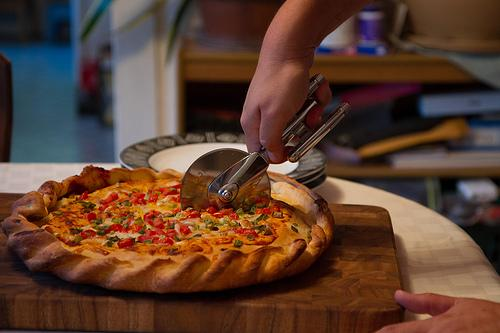Describe the type of pizza in the image and the surface on which it rests. The pizza has a breaded crust and various toppings like red peppers, placed on a dark brown cutting board. Determine the predominant sentiment that the image conveys. The image conveys a sense of an enjoyable meal time with pizza for dinner.  Analyze the quality of the image. The image appears cluttered with a desk in the background, and a blurry image of the hallway. What is the primary action happening in the image? A person is cutting a piece of pizza using a pizza cutter. Enumerate the types of objects on the table. There's a cutting board, a pizza, a pizza cutter, and three serving plates. Estimate the total number of objects present in the image. There are at least 16 distinctive objects, including the pizza cutter, cutting board, person's hand, plates, and table. What is the person's left hand holding in the image? The person's left hand is holding a pizza slicer. What material is the pizza cutter made of and what color is it? The pizza cutter is made of shiny, silver stainless steel. Are there five green plates next to the pizza? The image mentions "stack of plates," "three plates are on the table," and "plates have dark sim," but there is no mention of them being green or of there being five plates. Is the pizza cutter blade blue and made of plastic? In the image, the pizza cutter is described as "stainless steel pizza cutter" and "shiny metal," and there is no mention of it being blue or plastic. Is the pizza sitting on a glass cutting board? The pizza is described as being on a "wooden cutting board," "brown cutting board," and "dark brown cutting board," so it is not on a glass cutting board. Is there a clear vase of flowers on the table in the background? The image does not mention any vase, flowers, or clear objects on the background table. It only mentions objects like plates, cutting board, and tablecloth. Is the person holding the pizza cutter with their right hand? The image mentions "person left hand holding pizza slicer," so the person is not holding the pizza cutter with their right hand. Is the table covered with a bright red tablecloth? The table is described as having a "white table cloth," so a bright red tablecloth would be incorrect. 